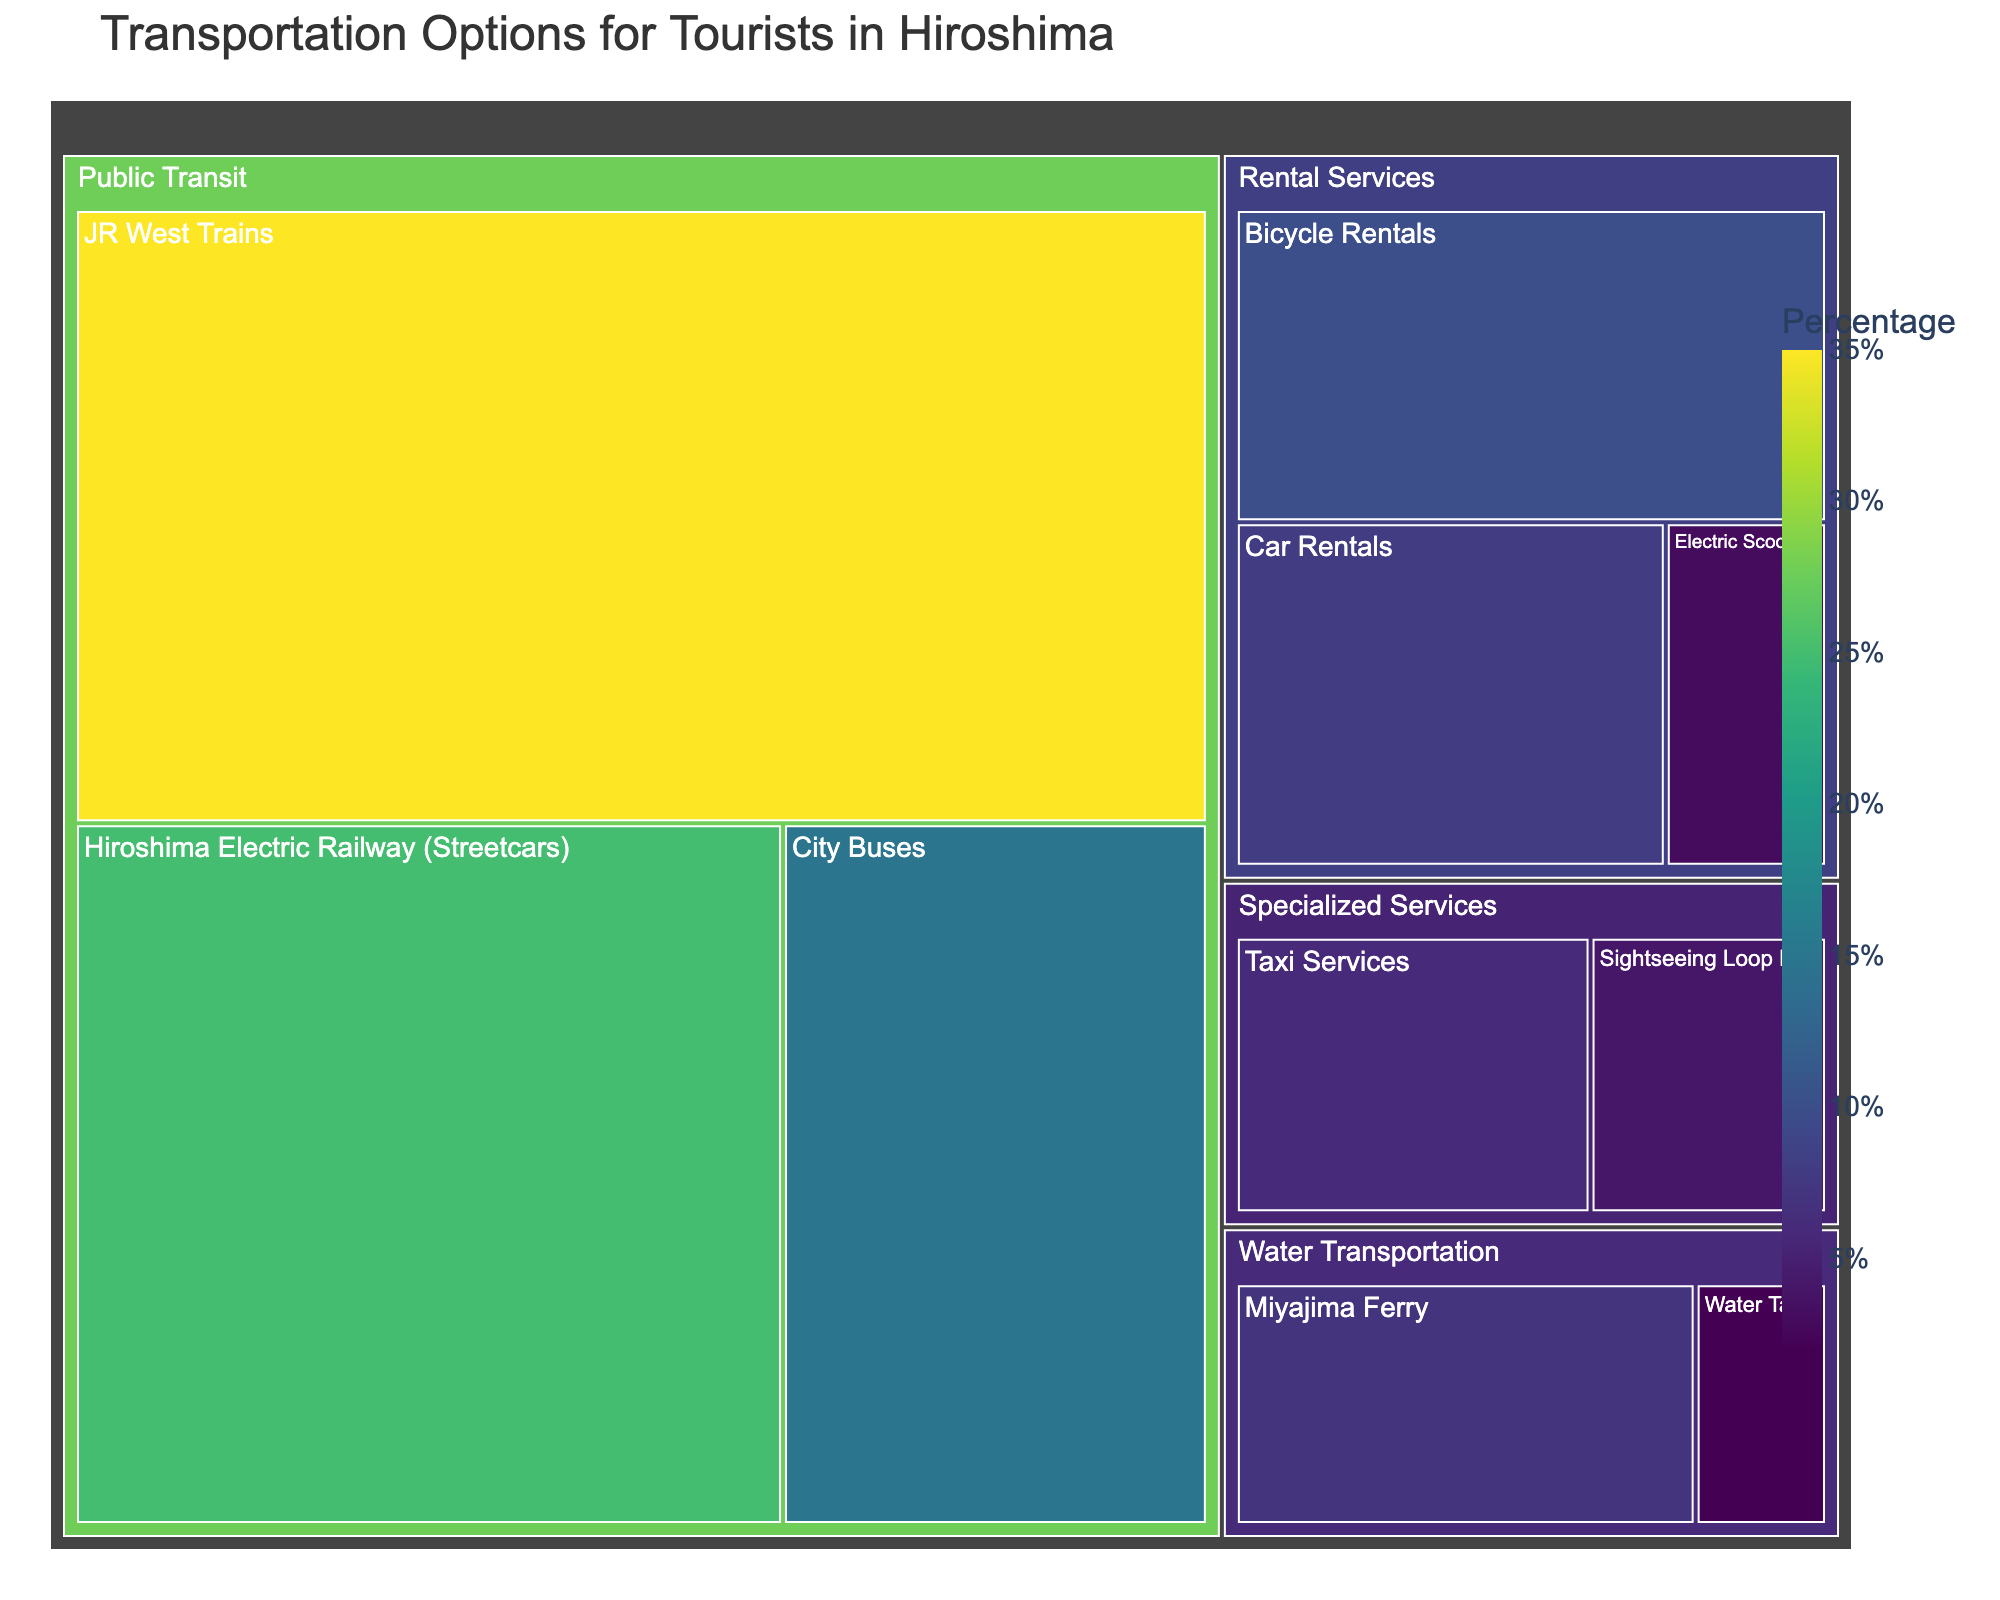What's the title of the Treemap? The title is typically located at the top of the chart and provides an overview of what the chart represents.
Answer: Transportation Options for Tourists in Hiroshima Which category has the highest value in the Treemap? To find the highest value category, look at the largest segment or the one with the highest percentage within the chart.
Answer: Public Transit How many subcategories are there in the Rental Services category? Count the number of smaller segments within the Rental Services section of the Treemap.
Answer: 3 What is the combined value of Water Transportation options? Sum up the values of all subcategories within the Water Transportation category: Miyajima Ferry and Water Taxis. 7 + 2 = 9
Answer: 9 Which has a higher value: City Buses or Car Rentals? Compare the values of the subcategories City Buses and Car Rentals.
Answer: City Buses What's the value difference between JR West Trains and Hiroshima Electric Railway (Streetcars)? Subtract the value of Hiroshima Electric Railway (Streetcars) from JR West Trains: 35 - 25 = 10
Answer: 10 What percentage of the transportation options does Bicycle Rentals represent in the Treemap? To find this, divide the value of Bicycle Rentals by the total of all values and multiply by 100. This requires knowing the sum of all values: 35 + 25 + 15 + 10 + 8 + 3 + 7 + 2 + 4 + 6 = 115. Then, (10/115) * 100 ≈ 8.7.
Answer: 8.7% Identify the smallest subcategory within Specialized Services. Look for the smallest segment within the Specialized Services category.
Answer: Sightseeing Loop Bus Are there more subcategories in Public Transit or Specialized Services? Count the number of subcategories within each main category. Public Transit has 3; Specialized Services has 2.
Answer: Public Transit Does Water Transportation have a higher total value than Rental Services? Calculate the total values for each category and compare: Water Transportation (7 + 2 = 9) vs. Rental Services (10 + 8 + 3 = 21).
Answer: No 